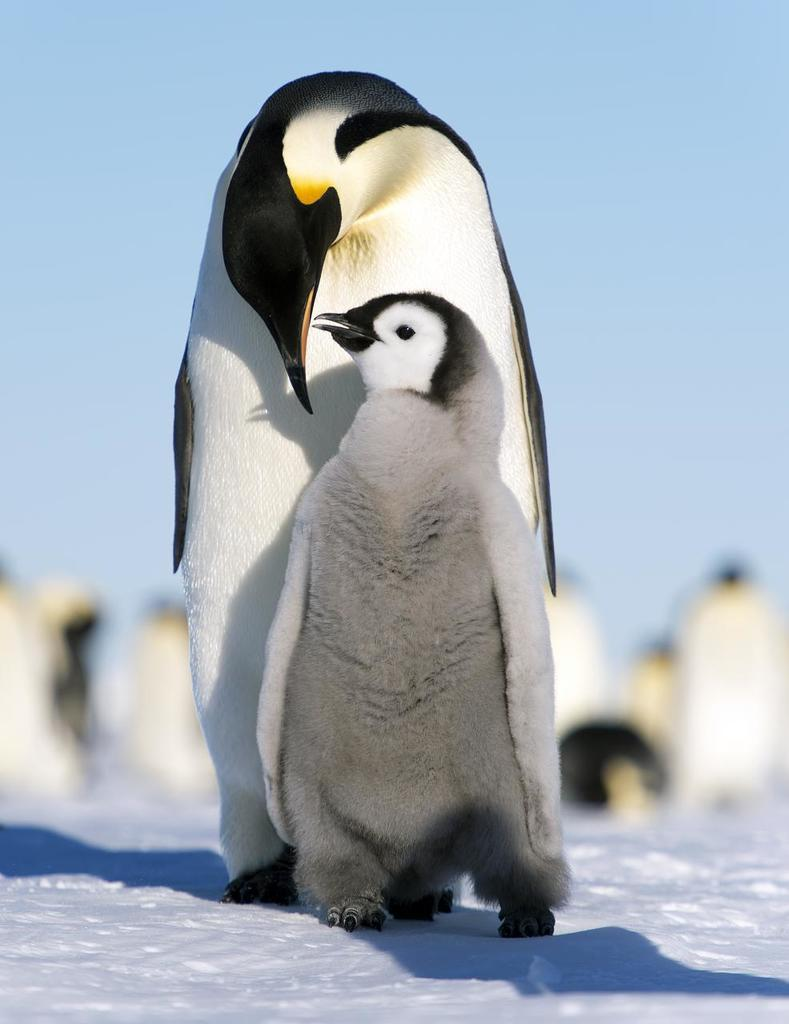What is the primary feature of the landscape in the image? There is snow in the image. What animals can be seen in the image? There are penguins in the image. What is visible in the background of the image? There is a sky visible in the background of the image. How many baskets can be seen in the image? There are no baskets present in the image. What type of wind can be seen blowing in the image? There is no wind visible in the image, and even if there were, we cannot see wind as it is invisible. 